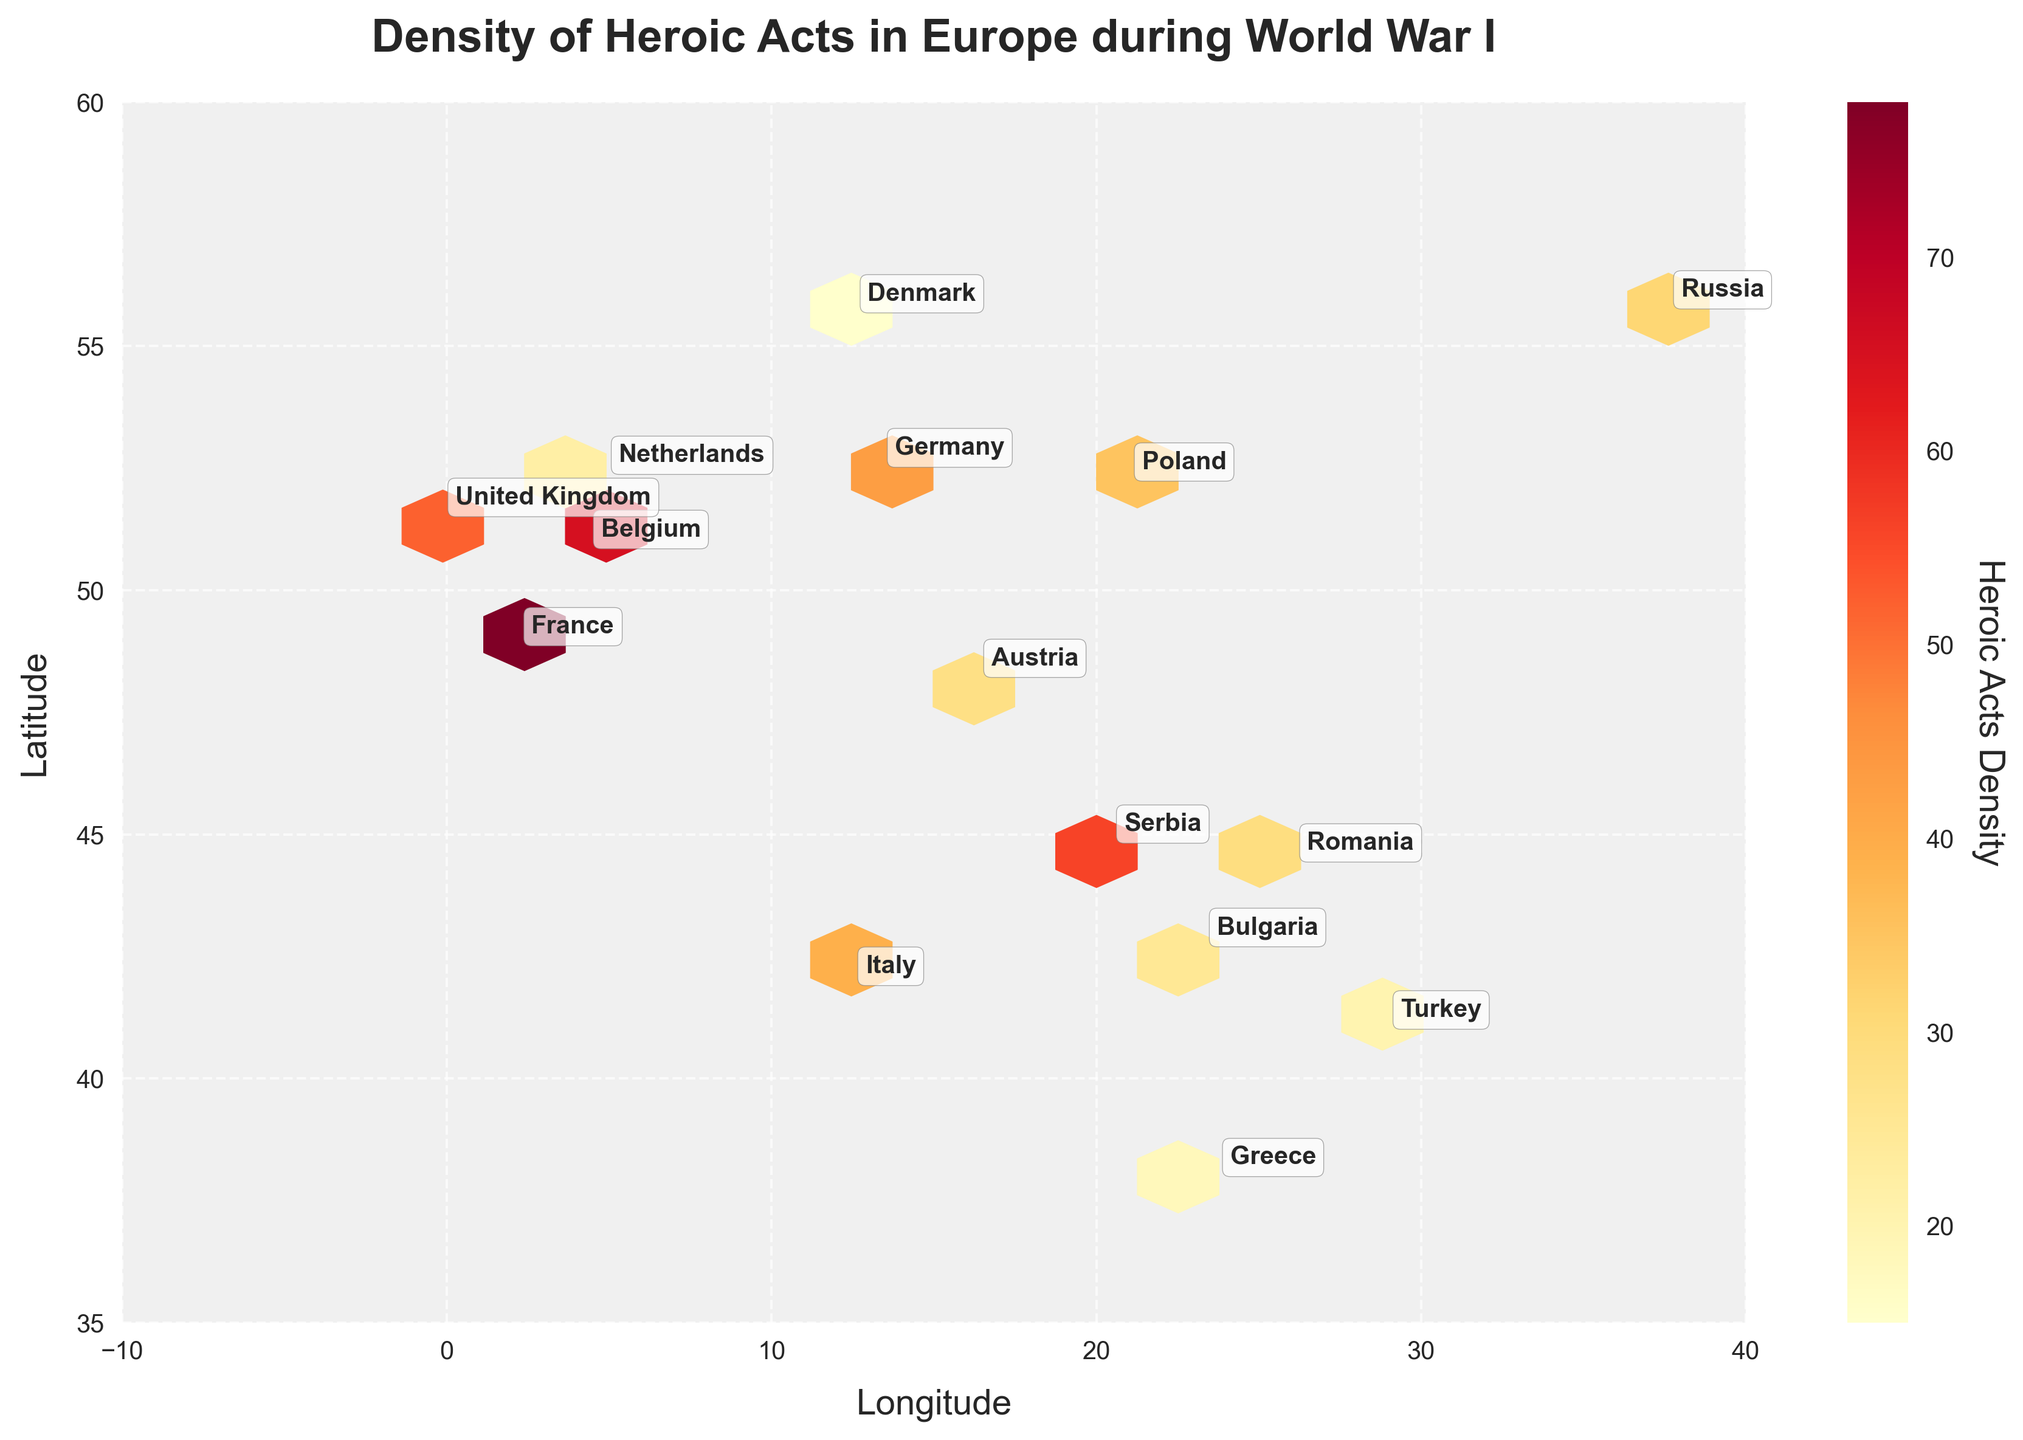What's the title of the figure? The title is displayed at the top of the figure. It gives an overview of what the figure represents.
Answer: Density of Heroic Acts in Europe during World War I Which country has the highest density of heroic acts? The density of heroic acts for each country can be observed through the hexbin plot and the annotations. France has the highest density with a value of 78.
Answer: France What is the range of the latitude shown in the plot? The latitude range is defined by the y-axis limits of the plot. The y-axis ranges from 35 to 60.
Answer: 35 to 60 Compare the density of heroic acts between France and Belgium. Which country has more? By looking at the annotations or the color intensities in the hexbin plot, France has a higher density of 78 compared to Belgium's 65.
Answer: France Which countries have a density of heroic acts between 20 and 30? By checking the annotations or the color values in the hexbin plot, Romania (29), Bulgaria (25), and Turkey (20) fall within this range.
Answer: Romania, Bulgaria, Turkey How does the density of heroic acts in Russia compare to that in Greece? By comparing the annotated densities or the colors in the hexbin plot, Russia has a density of 31 while Greece has a density of 18.
Answer: Russia has more What can be inferred about the geographical locations with higher densities of heroic acts? Areas with higher densities of heroic acts are mainly in Western Europe, indicated by more intense colors on the west side of the plot.
Answer: Western Europe How many countries are represented in the figure? Each country is annotated with its name on the hexbin plot. There are 15 countries annotated.
Answer: 15 What is the average density of heroic acts across all the countries? Summing the densities of all countries (78 + 65 + 52 + 43 + 39 + 31 + 28 + 56 + 35 + 29 + 22 + 18 + 25 + 20 + 15) gives 556. Dividing by the number of countries (15) results in an average of 556/15 ≈ 37.07.
Answer: 37.07 Are there any countries with heroic act densities under 20? By looking at the annotations, Denmark has a density of 15, which is the only country under 20.
Answer: Denmark 